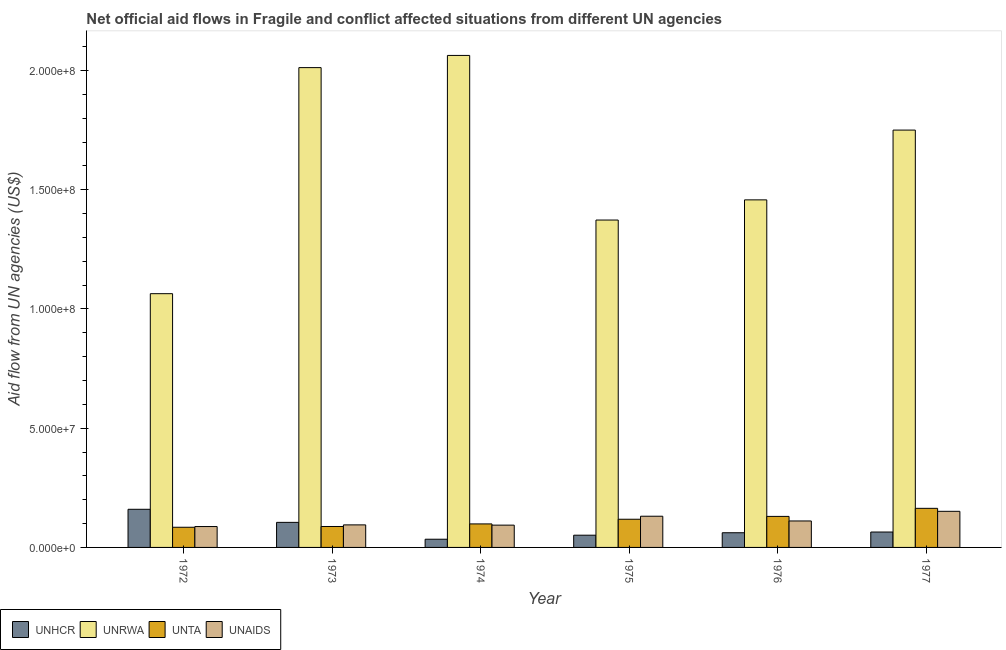How many different coloured bars are there?
Provide a succinct answer. 4. How many groups of bars are there?
Ensure brevity in your answer.  6. Are the number of bars per tick equal to the number of legend labels?
Offer a terse response. Yes. Are the number of bars on each tick of the X-axis equal?
Make the answer very short. Yes. What is the label of the 6th group of bars from the left?
Offer a very short reply. 1977. What is the amount of aid given by unta in 1975?
Offer a very short reply. 1.18e+07. Across all years, what is the maximum amount of aid given by unhcr?
Provide a short and direct response. 1.60e+07. Across all years, what is the minimum amount of aid given by unhcr?
Keep it short and to the point. 3.44e+06. In which year was the amount of aid given by unaids maximum?
Your answer should be very brief. 1977. What is the total amount of aid given by unhcr in the graph?
Offer a terse response. 4.77e+07. What is the difference between the amount of aid given by unta in 1972 and that in 1976?
Offer a very short reply. -4.55e+06. What is the difference between the amount of aid given by unrwa in 1976 and the amount of aid given by unhcr in 1975?
Give a very brief answer. 8.46e+06. What is the average amount of aid given by unaids per year?
Provide a short and direct response. 1.11e+07. In how many years, is the amount of aid given by unrwa greater than 150000000 US$?
Ensure brevity in your answer.  3. What is the ratio of the amount of aid given by unta in 1974 to that in 1975?
Keep it short and to the point. 0.83. Is the difference between the amount of aid given by unta in 1972 and 1973 greater than the difference between the amount of aid given by unrwa in 1972 and 1973?
Offer a very short reply. No. What is the difference between the highest and the second highest amount of aid given by unta?
Ensure brevity in your answer.  3.38e+06. What is the difference between the highest and the lowest amount of aid given by unaids?
Offer a terse response. 6.38e+06. What does the 2nd bar from the left in 1974 represents?
Provide a succinct answer. UNRWA. What does the 4th bar from the right in 1973 represents?
Your response must be concise. UNHCR. Is it the case that in every year, the sum of the amount of aid given by unhcr and amount of aid given by unrwa is greater than the amount of aid given by unta?
Keep it short and to the point. Yes. Are all the bars in the graph horizontal?
Offer a very short reply. No. Are the values on the major ticks of Y-axis written in scientific E-notation?
Your answer should be very brief. Yes. Does the graph contain grids?
Your answer should be compact. No. Where does the legend appear in the graph?
Your response must be concise. Bottom left. How many legend labels are there?
Keep it short and to the point. 4. What is the title of the graph?
Offer a terse response. Net official aid flows in Fragile and conflict affected situations from different UN agencies. Does "CO2 damage" appear as one of the legend labels in the graph?
Offer a terse response. No. What is the label or title of the X-axis?
Your answer should be compact. Year. What is the label or title of the Y-axis?
Provide a succinct answer. Aid flow from UN agencies (US$). What is the Aid flow from UN agencies (US$) of UNHCR in 1972?
Your answer should be very brief. 1.60e+07. What is the Aid flow from UN agencies (US$) in UNRWA in 1972?
Offer a terse response. 1.06e+08. What is the Aid flow from UN agencies (US$) in UNTA in 1972?
Your answer should be very brief. 8.46e+06. What is the Aid flow from UN agencies (US$) in UNAIDS in 1972?
Ensure brevity in your answer.  8.76e+06. What is the Aid flow from UN agencies (US$) of UNHCR in 1973?
Give a very brief answer. 1.05e+07. What is the Aid flow from UN agencies (US$) of UNRWA in 1973?
Your answer should be compact. 2.01e+08. What is the Aid flow from UN agencies (US$) of UNTA in 1973?
Give a very brief answer. 8.78e+06. What is the Aid flow from UN agencies (US$) of UNAIDS in 1973?
Your answer should be very brief. 9.45e+06. What is the Aid flow from UN agencies (US$) in UNHCR in 1974?
Provide a short and direct response. 3.44e+06. What is the Aid flow from UN agencies (US$) in UNRWA in 1974?
Give a very brief answer. 2.06e+08. What is the Aid flow from UN agencies (US$) in UNTA in 1974?
Your response must be concise. 9.86e+06. What is the Aid flow from UN agencies (US$) in UNAIDS in 1974?
Your answer should be very brief. 9.35e+06. What is the Aid flow from UN agencies (US$) in UNHCR in 1975?
Offer a very short reply. 5.13e+06. What is the Aid flow from UN agencies (US$) of UNRWA in 1975?
Your response must be concise. 1.37e+08. What is the Aid flow from UN agencies (US$) of UNTA in 1975?
Give a very brief answer. 1.18e+07. What is the Aid flow from UN agencies (US$) in UNAIDS in 1975?
Provide a succinct answer. 1.31e+07. What is the Aid flow from UN agencies (US$) of UNHCR in 1976?
Your response must be concise. 6.16e+06. What is the Aid flow from UN agencies (US$) in UNRWA in 1976?
Give a very brief answer. 1.46e+08. What is the Aid flow from UN agencies (US$) of UNTA in 1976?
Keep it short and to the point. 1.30e+07. What is the Aid flow from UN agencies (US$) in UNAIDS in 1976?
Provide a short and direct response. 1.11e+07. What is the Aid flow from UN agencies (US$) of UNHCR in 1977?
Your response must be concise. 6.46e+06. What is the Aid flow from UN agencies (US$) of UNRWA in 1977?
Offer a very short reply. 1.75e+08. What is the Aid flow from UN agencies (US$) of UNTA in 1977?
Your answer should be compact. 1.64e+07. What is the Aid flow from UN agencies (US$) in UNAIDS in 1977?
Your response must be concise. 1.51e+07. Across all years, what is the maximum Aid flow from UN agencies (US$) in UNHCR?
Ensure brevity in your answer.  1.60e+07. Across all years, what is the maximum Aid flow from UN agencies (US$) in UNRWA?
Ensure brevity in your answer.  2.06e+08. Across all years, what is the maximum Aid flow from UN agencies (US$) in UNTA?
Your answer should be very brief. 1.64e+07. Across all years, what is the maximum Aid flow from UN agencies (US$) in UNAIDS?
Provide a short and direct response. 1.51e+07. Across all years, what is the minimum Aid flow from UN agencies (US$) of UNHCR?
Offer a very short reply. 3.44e+06. Across all years, what is the minimum Aid flow from UN agencies (US$) of UNRWA?
Offer a very short reply. 1.06e+08. Across all years, what is the minimum Aid flow from UN agencies (US$) in UNTA?
Offer a terse response. 8.46e+06. Across all years, what is the minimum Aid flow from UN agencies (US$) in UNAIDS?
Give a very brief answer. 8.76e+06. What is the total Aid flow from UN agencies (US$) of UNHCR in the graph?
Provide a short and direct response. 4.77e+07. What is the total Aid flow from UN agencies (US$) of UNRWA in the graph?
Your response must be concise. 9.72e+08. What is the total Aid flow from UN agencies (US$) of UNTA in the graph?
Keep it short and to the point. 6.83e+07. What is the total Aid flow from UN agencies (US$) of UNAIDS in the graph?
Make the answer very short. 6.69e+07. What is the difference between the Aid flow from UN agencies (US$) in UNHCR in 1972 and that in 1973?
Offer a very short reply. 5.48e+06. What is the difference between the Aid flow from UN agencies (US$) in UNRWA in 1972 and that in 1973?
Your answer should be very brief. -9.48e+07. What is the difference between the Aid flow from UN agencies (US$) in UNTA in 1972 and that in 1973?
Offer a very short reply. -3.20e+05. What is the difference between the Aid flow from UN agencies (US$) in UNAIDS in 1972 and that in 1973?
Your answer should be very brief. -6.90e+05. What is the difference between the Aid flow from UN agencies (US$) in UNHCR in 1972 and that in 1974?
Offer a very short reply. 1.26e+07. What is the difference between the Aid flow from UN agencies (US$) in UNRWA in 1972 and that in 1974?
Your answer should be very brief. -9.99e+07. What is the difference between the Aid flow from UN agencies (US$) of UNTA in 1972 and that in 1974?
Your answer should be very brief. -1.40e+06. What is the difference between the Aid flow from UN agencies (US$) of UNAIDS in 1972 and that in 1974?
Your answer should be compact. -5.90e+05. What is the difference between the Aid flow from UN agencies (US$) of UNHCR in 1972 and that in 1975?
Ensure brevity in your answer.  1.09e+07. What is the difference between the Aid flow from UN agencies (US$) in UNRWA in 1972 and that in 1975?
Provide a succinct answer. -3.09e+07. What is the difference between the Aid flow from UN agencies (US$) of UNTA in 1972 and that in 1975?
Provide a short and direct response. -3.36e+06. What is the difference between the Aid flow from UN agencies (US$) in UNAIDS in 1972 and that in 1975?
Your answer should be compact. -4.32e+06. What is the difference between the Aid flow from UN agencies (US$) in UNHCR in 1972 and that in 1976?
Your response must be concise. 9.83e+06. What is the difference between the Aid flow from UN agencies (US$) of UNRWA in 1972 and that in 1976?
Provide a succinct answer. -3.93e+07. What is the difference between the Aid flow from UN agencies (US$) of UNTA in 1972 and that in 1976?
Your response must be concise. -4.55e+06. What is the difference between the Aid flow from UN agencies (US$) of UNAIDS in 1972 and that in 1976?
Offer a very short reply. -2.34e+06. What is the difference between the Aid flow from UN agencies (US$) in UNHCR in 1972 and that in 1977?
Provide a succinct answer. 9.53e+06. What is the difference between the Aid flow from UN agencies (US$) in UNRWA in 1972 and that in 1977?
Your response must be concise. -6.86e+07. What is the difference between the Aid flow from UN agencies (US$) of UNTA in 1972 and that in 1977?
Provide a succinct answer. -7.93e+06. What is the difference between the Aid flow from UN agencies (US$) of UNAIDS in 1972 and that in 1977?
Your answer should be very brief. -6.38e+06. What is the difference between the Aid flow from UN agencies (US$) in UNHCR in 1973 and that in 1974?
Keep it short and to the point. 7.07e+06. What is the difference between the Aid flow from UN agencies (US$) in UNRWA in 1973 and that in 1974?
Offer a terse response. -5.11e+06. What is the difference between the Aid flow from UN agencies (US$) in UNTA in 1973 and that in 1974?
Your answer should be compact. -1.08e+06. What is the difference between the Aid flow from UN agencies (US$) of UNHCR in 1973 and that in 1975?
Give a very brief answer. 5.38e+06. What is the difference between the Aid flow from UN agencies (US$) in UNRWA in 1973 and that in 1975?
Offer a terse response. 6.39e+07. What is the difference between the Aid flow from UN agencies (US$) in UNTA in 1973 and that in 1975?
Provide a succinct answer. -3.04e+06. What is the difference between the Aid flow from UN agencies (US$) in UNAIDS in 1973 and that in 1975?
Give a very brief answer. -3.63e+06. What is the difference between the Aid flow from UN agencies (US$) in UNHCR in 1973 and that in 1976?
Your response must be concise. 4.35e+06. What is the difference between the Aid flow from UN agencies (US$) of UNRWA in 1973 and that in 1976?
Offer a terse response. 5.55e+07. What is the difference between the Aid flow from UN agencies (US$) of UNTA in 1973 and that in 1976?
Your response must be concise. -4.23e+06. What is the difference between the Aid flow from UN agencies (US$) in UNAIDS in 1973 and that in 1976?
Ensure brevity in your answer.  -1.65e+06. What is the difference between the Aid flow from UN agencies (US$) of UNHCR in 1973 and that in 1977?
Provide a short and direct response. 4.05e+06. What is the difference between the Aid flow from UN agencies (US$) in UNRWA in 1973 and that in 1977?
Provide a succinct answer. 2.62e+07. What is the difference between the Aid flow from UN agencies (US$) in UNTA in 1973 and that in 1977?
Provide a short and direct response. -7.61e+06. What is the difference between the Aid flow from UN agencies (US$) of UNAIDS in 1973 and that in 1977?
Your answer should be compact. -5.69e+06. What is the difference between the Aid flow from UN agencies (US$) in UNHCR in 1974 and that in 1975?
Give a very brief answer. -1.69e+06. What is the difference between the Aid flow from UN agencies (US$) in UNRWA in 1974 and that in 1975?
Offer a very short reply. 6.90e+07. What is the difference between the Aid flow from UN agencies (US$) of UNTA in 1974 and that in 1975?
Make the answer very short. -1.96e+06. What is the difference between the Aid flow from UN agencies (US$) in UNAIDS in 1974 and that in 1975?
Ensure brevity in your answer.  -3.73e+06. What is the difference between the Aid flow from UN agencies (US$) in UNHCR in 1974 and that in 1976?
Offer a terse response. -2.72e+06. What is the difference between the Aid flow from UN agencies (US$) in UNRWA in 1974 and that in 1976?
Make the answer very short. 6.06e+07. What is the difference between the Aid flow from UN agencies (US$) of UNTA in 1974 and that in 1976?
Keep it short and to the point. -3.15e+06. What is the difference between the Aid flow from UN agencies (US$) of UNAIDS in 1974 and that in 1976?
Your answer should be very brief. -1.75e+06. What is the difference between the Aid flow from UN agencies (US$) in UNHCR in 1974 and that in 1977?
Offer a very short reply. -3.02e+06. What is the difference between the Aid flow from UN agencies (US$) of UNRWA in 1974 and that in 1977?
Offer a terse response. 3.13e+07. What is the difference between the Aid flow from UN agencies (US$) of UNTA in 1974 and that in 1977?
Ensure brevity in your answer.  -6.53e+06. What is the difference between the Aid flow from UN agencies (US$) of UNAIDS in 1974 and that in 1977?
Your answer should be very brief. -5.79e+06. What is the difference between the Aid flow from UN agencies (US$) in UNHCR in 1975 and that in 1976?
Provide a short and direct response. -1.03e+06. What is the difference between the Aid flow from UN agencies (US$) of UNRWA in 1975 and that in 1976?
Your answer should be compact. -8.46e+06. What is the difference between the Aid flow from UN agencies (US$) of UNTA in 1975 and that in 1976?
Make the answer very short. -1.19e+06. What is the difference between the Aid flow from UN agencies (US$) in UNAIDS in 1975 and that in 1976?
Offer a very short reply. 1.98e+06. What is the difference between the Aid flow from UN agencies (US$) of UNHCR in 1975 and that in 1977?
Your response must be concise. -1.33e+06. What is the difference between the Aid flow from UN agencies (US$) in UNRWA in 1975 and that in 1977?
Keep it short and to the point. -3.77e+07. What is the difference between the Aid flow from UN agencies (US$) in UNTA in 1975 and that in 1977?
Offer a terse response. -4.57e+06. What is the difference between the Aid flow from UN agencies (US$) of UNAIDS in 1975 and that in 1977?
Keep it short and to the point. -2.06e+06. What is the difference between the Aid flow from UN agencies (US$) in UNHCR in 1976 and that in 1977?
Ensure brevity in your answer.  -3.00e+05. What is the difference between the Aid flow from UN agencies (US$) of UNRWA in 1976 and that in 1977?
Provide a succinct answer. -2.93e+07. What is the difference between the Aid flow from UN agencies (US$) in UNTA in 1976 and that in 1977?
Ensure brevity in your answer.  -3.38e+06. What is the difference between the Aid flow from UN agencies (US$) of UNAIDS in 1976 and that in 1977?
Your answer should be very brief. -4.04e+06. What is the difference between the Aid flow from UN agencies (US$) of UNHCR in 1972 and the Aid flow from UN agencies (US$) of UNRWA in 1973?
Provide a short and direct response. -1.85e+08. What is the difference between the Aid flow from UN agencies (US$) in UNHCR in 1972 and the Aid flow from UN agencies (US$) in UNTA in 1973?
Make the answer very short. 7.21e+06. What is the difference between the Aid flow from UN agencies (US$) in UNHCR in 1972 and the Aid flow from UN agencies (US$) in UNAIDS in 1973?
Your response must be concise. 6.54e+06. What is the difference between the Aid flow from UN agencies (US$) of UNRWA in 1972 and the Aid flow from UN agencies (US$) of UNTA in 1973?
Ensure brevity in your answer.  9.76e+07. What is the difference between the Aid flow from UN agencies (US$) of UNRWA in 1972 and the Aid flow from UN agencies (US$) of UNAIDS in 1973?
Keep it short and to the point. 9.70e+07. What is the difference between the Aid flow from UN agencies (US$) of UNTA in 1972 and the Aid flow from UN agencies (US$) of UNAIDS in 1973?
Provide a short and direct response. -9.90e+05. What is the difference between the Aid flow from UN agencies (US$) of UNHCR in 1972 and the Aid flow from UN agencies (US$) of UNRWA in 1974?
Your response must be concise. -1.90e+08. What is the difference between the Aid flow from UN agencies (US$) in UNHCR in 1972 and the Aid flow from UN agencies (US$) in UNTA in 1974?
Your response must be concise. 6.13e+06. What is the difference between the Aid flow from UN agencies (US$) of UNHCR in 1972 and the Aid flow from UN agencies (US$) of UNAIDS in 1974?
Provide a succinct answer. 6.64e+06. What is the difference between the Aid flow from UN agencies (US$) of UNRWA in 1972 and the Aid flow from UN agencies (US$) of UNTA in 1974?
Offer a terse response. 9.65e+07. What is the difference between the Aid flow from UN agencies (US$) of UNRWA in 1972 and the Aid flow from UN agencies (US$) of UNAIDS in 1974?
Give a very brief answer. 9.70e+07. What is the difference between the Aid flow from UN agencies (US$) in UNTA in 1972 and the Aid flow from UN agencies (US$) in UNAIDS in 1974?
Ensure brevity in your answer.  -8.90e+05. What is the difference between the Aid flow from UN agencies (US$) in UNHCR in 1972 and the Aid flow from UN agencies (US$) in UNRWA in 1975?
Offer a terse response. -1.21e+08. What is the difference between the Aid flow from UN agencies (US$) in UNHCR in 1972 and the Aid flow from UN agencies (US$) in UNTA in 1975?
Your answer should be compact. 4.17e+06. What is the difference between the Aid flow from UN agencies (US$) in UNHCR in 1972 and the Aid flow from UN agencies (US$) in UNAIDS in 1975?
Provide a short and direct response. 2.91e+06. What is the difference between the Aid flow from UN agencies (US$) in UNRWA in 1972 and the Aid flow from UN agencies (US$) in UNTA in 1975?
Make the answer very short. 9.46e+07. What is the difference between the Aid flow from UN agencies (US$) of UNRWA in 1972 and the Aid flow from UN agencies (US$) of UNAIDS in 1975?
Your answer should be compact. 9.33e+07. What is the difference between the Aid flow from UN agencies (US$) in UNTA in 1972 and the Aid flow from UN agencies (US$) in UNAIDS in 1975?
Your answer should be compact. -4.62e+06. What is the difference between the Aid flow from UN agencies (US$) in UNHCR in 1972 and the Aid flow from UN agencies (US$) in UNRWA in 1976?
Keep it short and to the point. -1.30e+08. What is the difference between the Aid flow from UN agencies (US$) of UNHCR in 1972 and the Aid flow from UN agencies (US$) of UNTA in 1976?
Offer a terse response. 2.98e+06. What is the difference between the Aid flow from UN agencies (US$) of UNHCR in 1972 and the Aid flow from UN agencies (US$) of UNAIDS in 1976?
Ensure brevity in your answer.  4.89e+06. What is the difference between the Aid flow from UN agencies (US$) in UNRWA in 1972 and the Aid flow from UN agencies (US$) in UNTA in 1976?
Keep it short and to the point. 9.34e+07. What is the difference between the Aid flow from UN agencies (US$) in UNRWA in 1972 and the Aid flow from UN agencies (US$) in UNAIDS in 1976?
Offer a very short reply. 9.53e+07. What is the difference between the Aid flow from UN agencies (US$) in UNTA in 1972 and the Aid flow from UN agencies (US$) in UNAIDS in 1976?
Offer a very short reply. -2.64e+06. What is the difference between the Aid flow from UN agencies (US$) of UNHCR in 1972 and the Aid flow from UN agencies (US$) of UNRWA in 1977?
Offer a terse response. -1.59e+08. What is the difference between the Aid flow from UN agencies (US$) of UNHCR in 1972 and the Aid flow from UN agencies (US$) of UNTA in 1977?
Your response must be concise. -4.00e+05. What is the difference between the Aid flow from UN agencies (US$) of UNHCR in 1972 and the Aid flow from UN agencies (US$) of UNAIDS in 1977?
Ensure brevity in your answer.  8.50e+05. What is the difference between the Aid flow from UN agencies (US$) of UNRWA in 1972 and the Aid flow from UN agencies (US$) of UNTA in 1977?
Offer a terse response. 9.00e+07. What is the difference between the Aid flow from UN agencies (US$) of UNRWA in 1972 and the Aid flow from UN agencies (US$) of UNAIDS in 1977?
Your answer should be compact. 9.13e+07. What is the difference between the Aid flow from UN agencies (US$) of UNTA in 1972 and the Aid flow from UN agencies (US$) of UNAIDS in 1977?
Give a very brief answer. -6.68e+06. What is the difference between the Aid flow from UN agencies (US$) in UNHCR in 1973 and the Aid flow from UN agencies (US$) in UNRWA in 1974?
Your response must be concise. -1.96e+08. What is the difference between the Aid flow from UN agencies (US$) in UNHCR in 1973 and the Aid flow from UN agencies (US$) in UNTA in 1974?
Your response must be concise. 6.50e+05. What is the difference between the Aid flow from UN agencies (US$) in UNHCR in 1973 and the Aid flow from UN agencies (US$) in UNAIDS in 1974?
Offer a terse response. 1.16e+06. What is the difference between the Aid flow from UN agencies (US$) of UNRWA in 1973 and the Aid flow from UN agencies (US$) of UNTA in 1974?
Offer a terse response. 1.91e+08. What is the difference between the Aid flow from UN agencies (US$) of UNRWA in 1973 and the Aid flow from UN agencies (US$) of UNAIDS in 1974?
Offer a terse response. 1.92e+08. What is the difference between the Aid flow from UN agencies (US$) of UNTA in 1973 and the Aid flow from UN agencies (US$) of UNAIDS in 1974?
Your answer should be very brief. -5.70e+05. What is the difference between the Aid flow from UN agencies (US$) in UNHCR in 1973 and the Aid flow from UN agencies (US$) in UNRWA in 1975?
Offer a very short reply. -1.27e+08. What is the difference between the Aid flow from UN agencies (US$) in UNHCR in 1973 and the Aid flow from UN agencies (US$) in UNTA in 1975?
Make the answer very short. -1.31e+06. What is the difference between the Aid flow from UN agencies (US$) of UNHCR in 1973 and the Aid flow from UN agencies (US$) of UNAIDS in 1975?
Keep it short and to the point. -2.57e+06. What is the difference between the Aid flow from UN agencies (US$) in UNRWA in 1973 and the Aid flow from UN agencies (US$) in UNTA in 1975?
Provide a short and direct response. 1.89e+08. What is the difference between the Aid flow from UN agencies (US$) in UNRWA in 1973 and the Aid flow from UN agencies (US$) in UNAIDS in 1975?
Your answer should be very brief. 1.88e+08. What is the difference between the Aid flow from UN agencies (US$) of UNTA in 1973 and the Aid flow from UN agencies (US$) of UNAIDS in 1975?
Keep it short and to the point. -4.30e+06. What is the difference between the Aid flow from UN agencies (US$) of UNHCR in 1973 and the Aid flow from UN agencies (US$) of UNRWA in 1976?
Provide a succinct answer. -1.35e+08. What is the difference between the Aid flow from UN agencies (US$) of UNHCR in 1973 and the Aid flow from UN agencies (US$) of UNTA in 1976?
Your answer should be compact. -2.50e+06. What is the difference between the Aid flow from UN agencies (US$) of UNHCR in 1973 and the Aid flow from UN agencies (US$) of UNAIDS in 1976?
Your answer should be very brief. -5.90e+05. What is the difference between the Aid flow from UN agencies (US$) of UNRWA in 1973 and the Aid flow from UN agencies (US$) of UNTA in 1976?
Offer a very short reply. 1.88e+08. What is the difference between the Aid flow from UN agencies (US$) in UNRWA in 1973 and the Aid flow from UN agencies (US$) in UNAIDS in 1976?
Make the answer very short. 1.90e+08. What is the difference between the Aid flow from UN agencies (US$) in UNTA in 1973 and the Aid flow from UN agencies (US$) in UNAIDS in 1976?
Your answer should be compact. -2.32e+06. What is the difference between the Aid flow from UN agencies (US$) in UNHCR in 1973 and the Aid flow from UN agencies (US$) in UNRWA in 1977?
Keep it short and to the point. -1.64e+08. What is the difference between the Aid flow from UN agencies (US$) in UNHCR in 1973 and the Aid flow from UN agencies (US$) in UNTA in 1977?
Keep it short and to the point. -5.88e+06. What is the difference between the Aid flow from UN agencies (US$) of UNHCR in 1973 and the Aid flow from UN agencies (US$) of UNAIDS in 1977?
Provide a succinct answer. -4.63e+06. What is the difference between the Aid flow from UN agencies (US$) in UNRWA in 1973 and the Aid flow from UN agencies (US$) in UNTA in 1977?
Keep it short and to the point. 1.85e+08. What is the difference between the Aid flow from UN agencies (US$) of UNRWA in 1973 and the Aid flow from UN agencies (US$) of UNAIDS in 1977?
Give a very brief answer. 1.86e+08. What is the difference between the Aid flow from UN agencies (US$) of UNTA in 1973 and the Aid flow from UN agencies (US$) of UNAIDS in 1977?
Provide a succinct answer. -6.36e+06. What is the difference between the Aid flow from UN agencies (US$) in UNHCR in 1974 and the Aid flow from UN agencies (US$) in UNRWA in 1975?
Give a very brief answer. -1.34e+08. What is the difference between the Aid flow from UN agencies (US$) in UNHCR in 1974 and the Aid flow from UN agencies (US$) in UNTA in 1975?
Keep it short and to the point. -8.38e+06. What is the difference between the Aid flow from UN agencies (US$) of UNHCR in 1974 and the Aid flow from UN agencies (US$) of UNAIDS in 1975?
Ensure brevity in your answer.  -9.64e+06. What is the difference between the Aid flow from UN agencies (US$) in UNRWA in 1974 and the Aid flow from UN agencies (US$) in UNTA in 1975?
Keep it short and to the point. 1.94e+08. What is the difference between the Aid flow from UN agencies (US$) in UNRWA in 1974 and the Aid flow from UN agencies (US$) in UNAIDS in 1975?
Provide a succinct answer. 1.93e+08. What is the difference between the Aid flow from UN agencies (US$) of UNTA in 1974 and the Aid flow from UN agencies (US$) of UNAIDS in 1975?
Your response must be concise. -3.22e+06. What is the difference between the Aid flow from UN agencies (US$) in UNHCR in 1974 and the Aid flow from UN agencies (US$) in UNRWA in 1976?
Offer a very short reply. -1.42e+08. What is the difference between the Aid flow from UN agencies (US$) in UNHCR in 1974 and the Aid flow from UN agencies (US$) in UNTA in 1976?
Make the answer very short. -9.57e+06. What is the difference between the Aid flow from UN agencies (US$) of UNHCR in 1974 and the Aid flow from UN agencies (US$) of UNAIDS in 1976?
Keep it short and to the point. -7.66e+06. What is the difference between the Aid flow from UN agencies (US$) of UNRWA in 1974 and the Aid flow from UN agencies (US$) of UNTA in 1976?
Keep it short and to the point. 1.93e+08. What is the difference between the Aid flow from UN agencies (US$) of UNRWA in 1974 and the Aid flow from UN agencies (US$) of UNAIDS in 1976?
Your answer should be very brief. 1.95e+08. What is the difference between the Aid flow from UN agencies (US$) of UNTA in 1974 and the Aid flow from UN agencies (US$) of UNAIDS in 1976?
Keep it short and to the point. -1.24e+06. What is the difference between the Aid flow from UN agencies (US$) of UNHCR in 1974 and the Aid flow from UN agencies (US$) of UNRWA in 1977?
Ensure brevity in your answer.  -1.72e+08. What is the difference between the Aid flow from UN agencies (US$) in UNHCR in 1974 and the Aid flow from UN agencies (US$) in UNTA in 1977?
Give a very brief answer. -1.30e+07. What is the difference between the Aid flow from UN agencies (US$) in UNHCR in 1974 and the Aid flow from UN agencies (US$) in UNAIDS in 1977?
Give a very brief answer. -1.17e+07. What is the difference between the Aid flow from UN agencies (US$) of UNRWA in 1974 and the Aid flow from UN agencies (US$) of UNTA in 1977?
Your answer should be very brief. 1.90e+08. What is the difference between the Aid flow from UN agencies (US$) of UNRWA in 1974 and the Aid flow from UN agencies (US$) of UNAIDS in 1977?
Your response must be concise. 1.91e+08. What is the difference between the Aid flow from UN agencies (US$) in UNTA in 1974 and the Aid flow from UN agencies (US$) in UNAIDS in 1977?
Keep it short and to the point. -5.28e+06. What is the difference between the Aid flow from UN agencies (US$) of UNHCR in 1975 and the Aid flow from UN agencies (US$) of UNRWA in 1976?
Your response must be concise. -1.41e+08. What is the difference between the Aid flow from UN agencies (US$) in UNHCR in 1975 and the Aid flow from UN agencies (US$) in UNTA in 1976?
Provide a short and direct response. -7.88e+06. What is the difference between the Aid flow from UN agencies (US$) in UNHCR in 1975 and the Aid flow from UN agencies (US$) in UNAIDS in 1976?
Make the answer very short. -5.97e+06. What is the difference between the Aid flow from UN agencies (US$) in UNRWA in 1975 and the Aid flow from UN agencies (US$) in UNTA in 1976?
Your response must be concise. 1.24e+08. What is the difference between the Aid flow from UN agencies (US$) in UNRWA in 1975 and the Aid flow from UN agencies (US$) in UNAIDS in 1976?
Your answer should be very brief. 1.26e+08. What is the difference between the Aid flow from UN agencies (US$) of UNTA in 1975 and the Aid flow from UN agencies (US$) of UNAIDS in 1976?
Give a very brief answer. 7.20e+05. What is the difference between the Aid flow from UN agencies (US$) of UNHCR in 1975 and the Aid flow from UN agencies (US$) of UNRWA in 1977?
Offer a very short reply. -1.70e+08. What is the difference between the Aid flow from UN agencies (US$) in UNHCR in 1975 and the Aid flow from UN agencies (US$) in UNTA in 1977?
Ensure brevity in your answer.  -1.13e+07. What is the difference between the Aid flow from UN agencies (US$) of UNHCR in 1975 and the Aid flow from UN agencies (US$) of UNAIDS in 1977?
Your answer should be compact. -1.00e+07. What is the difference between the Aid flow from UN agencies (US$) in UNRWA in 1975 and the Aid flow from UN agencies (US$) in UNTA in 1977?
Your answer should be very brief. 1.21e+08. What is the difference between the Aid flow from UN agencies (US$) of UNRWA in 1975 and the Aid flow from UN agencies (US$) of UNAIDS in 1977?
Provide a short and direct response. 1.22e+08. What is the difference between the Aid flow from UN agencies (US$) in UNTA in 1975 and the Aid flow from UN agencies (US$) in UNAIDS in 1977?
Keep it short and to the point. -3.32e+06. What is the difference between the Aid flow from UN agencies (US$) of UNHCR in 1976 and the Aid flow from UN agencies (US$) of UNRWA in 1977?
Your answer should be compact. -1.69e+08. What is the difference between the Aid flow from UN agencies (US$) of UNHCR in 1976 and the Aid flow from UN agencies (US$) of UNTA in 1977?
Your response must be concise. -1.02e+07. What is the difference between the Aid flow from UN agencies (US$) in UNHCR in 1976 and the Aid flow from UN agencies (US$) in UNAIDS in 1977?
Make the answer very short. -8.98e+06. What is the difference between the Aid flow from UN agencies (US$) in UNRWA in 1976 and the Aid flow from UN agencies (US$) in UNTA in 1977?
Give a very brief answer. 1.29e+08. What is the difference between the Aid flow from UN agencies (US$) of UNRWA in 1976 and the Aid flow from UN agencies (US$) of UNAIDS in 1977?
Give a very brief answer. 1.31e+08. What is the difference between the Aid flow from UN agencies (US$) in UNTA in 1976 and the Aid flow from UN agencies (US$) in UNAIDS in 1977?
Provide a succinct answer. -2.13e+06. What is the average Aid flow from UN agencies (US$) of UNHCR per year?
Keep it short and to the point. 7.95e+06. What is the average Aid flow from UN agencies (US$) in UNRWA per year?
Your answer should be very brief. 1.62e+08. What is the average Aid flow from UN agencies (US$) in UNTA per year?
Your answer should be compact. 1.14e+07. What is the average Aid flow from UN agencies (US$) in UNAIDS per year?
Provide a succinct answer. 1.11e+07. In the year 1972, what is the difference between the Aid flow from UN agencies (US$) in UNHCR and Aid flow from UN agencies (US$) in UNRWA?
Provide a succinct answer. -9.04e+07. In the year 1972, what is the difference between the Aid flow from UN agencies (US$) in UNHCR and Aid flow from UN agencies (US$) in UNTA?
Your response must be concise. 7.53e+06. In the year 1972, what is the difference between the Aid flow from UN agencies (US$) of UNHCR and Aid flow from UN agencies (US$) of UNAIDS?
Provide a short and direct response. 7.23e+06. In the year 1972, what is the difference between the Aid flow from UN agencies (US$) of UNRWA and Aid flow from UN agencies (US$) of UNTA?
Keep it short and to the point. 9.79e+07. In the year 1972, what is the difference between the Aid flow from UN agencies (US$) of UNRWA and Aid flow from UN agencies (US$) of UNAIDS?
Offer a very short reply. 9.76e+07. In the year 1972, what is the difference between the Aid flow from UN agencies (US$) in UNTA and Aid flow from UN agencies (US$) in UNAIDS?
Offer a terse response. -3.00e+05. In the year 1973, what is the difference between the Aid flow from UN agencies (US$) in UNHCR and Aid flow from UN agencies (US$) in UNRWA?
Make the answer very short. -1.91e+08. In the year 1973, what is the difference between the Aid flow from UN agencies (US$) in UNHCR and Aid flow from UN agencies (US$) in UNTA?
Provide a succinct answer. 1.73e+06. In the year 1973, what is the difference between the Aid flow from UN agencies (US$) of UNHCR and Aid flow from UN agencies (US$) of UNAIDS?
Provide a short and direct response. 1.06e+06. In the year 1973, what is the difference between the Aid flow from UN agencies (US$) in UNRWA and Aid flow from UN agencies (US$) in UNTA?
Your answer should be compact. 1.92e+08. In the year 1973, what is the difference between the Aid flow from UN agencies (US$) of UNRWA and Aid flow from UN agencies (US$) of UNAIDS?
Keep it short and to the point. 1.92e+08. In the year 1973, what is the difference between the Aid flow from UN agencies (US$) of UNTA and Aid flow from UN agencies (US$) of UNAIDS?
Offer a terse response. -6.70e+05. In the year 1974, what is the difference between the Aid flow from UN agencies (US$) in UNHCR and Aid flow from UN agencies (US$) in UNRWA?
Offer a very short reply. -2.03e+08. In the year 1974, what is the difference between the Aid flow from UN agencies (US$) in UNHCR and Aid flow from UN agencies (US$) in UNTA?
Offer a very short reply. -6.42e+06. In the year 1974, what is the difference between the Aid flow from UN agencies (US$) of UNHCR and Aid flow from UN agencies (US$) of UNAIDS?
Make the answer very short. -5.91e+06. In the year 1974, what is the difference between the Aid flow from UN agencies (US$) in UNRWA and Aid flow from UN agencies (US$) in UNTA?
Your answer should be compact. 1.96e+08. In the year 1974, what is the difference between the Aid flow from UN agencies (US$) in UNRWA and Aid flow from UN agencies (US$) in UNAIDS?
Your answer should be compact. 1.97e+08. In the year 1974, what is the difference between the Aid flow from UN agencies (US$) of UNTA and Aid flow from UN agencies (US$) of UNAIDS?
Your response must be concise. 5.10e+05. In the year 1975, what is the difference between the Aid flow from UN agencies (US$) of UNHCR and Aid flow from UN agencies (US$) of UNRWA?
Offer a very short reply. -1.32e+08. In the year 1975, what is the difference between the Aid flow from UN agencies (US$) in UNHCR and Aid flow from UN agencies (US$) in UNTA?
Give a very brief answer. -6.69e+06. In the year 1975, what is the difference between the Aid flow from UN agencies (US$) in UNHCR and Aid flow from UN agencies (US$) in UNAIDS?
Provide a succinct answer. -7.95e+06. In the year 1975, what is the difference between the Aid flow from UN agencies (US$) of UNRWA and Aid flow from UN agencies (US$) of UNTA?
Keep it short and to the point. 1.25e+08. In the year 1975, what is the difference between the Aid flow from UN agencies (US$) in UNRWA and Aid flow from UN agencies (US$) in UNAIDS?
Offer a terse response. 1.24e+08. In the year 1975, what is the difference between the Aid flow from UN agencies (US$) of UNTA and Aid flow from UN agencies (US$) of UNAIDS?
Make the answer very short. -1.26e+06. In the year 1976, what is the difference between the Aid flow from UN agencies (US$) in UNHCR and Aid flow from UN agencies (US$) in UNRWA?
Your response must be concise. -1.40e+08. In the year 1976, what is the difference between the Aid flow from UN agencies (US$) in UNHCR and Aid flow from UN agencies (US$) in UNTA?
Your answer should be compact. -6.85e+06. In the year 1976, what is the difference between the Aid flow from UN agencies (US$) of UNHCR and Aid flow from UN agencies (US$) of UNAIDS?
Ensure brevity in your answer.  -4.94e+06. In the year 1976, what is the difference between the Aid flow from UN agencies (US$) in UNRWA and Aid flow from UN agencies (US$) in UNTA?
Provide a short and direct response. 1.33e+08. In the year 1976, what is the difference between the Aid flow from UN agencies (US$) of UNRWA and Aid flow from UN agencies (US$) of UNAIDS?
Your answer should be compact. 1.35e+08. In the year 1976, what is the difference between the Aid flow from UN agencies (US$) in UNTA and Aid flow from UN agencies (US$) in UNAIDS?
Provide a succinct answer. 1.91e+06. In the year 1977, what is the difference between the Aid flow from UN agencies (US$) in UNHCR and Aid flow from UN agencies (US$) in UNRWA?
Ensure brevity in your answer.  -1.69e+08. In the year 1977, what is the difference between the Aid flow from UN agencies (US$) of UNHCR and Aid flow from UN agencies (US$) of UNTA?
Give a very brief answer. -9.93e+06. In the year 1977, what is the difference between the Aid flow from UN agencies (US$) of UNHCR and Aid flow from UN agencies (US$) of UNAIDS?
Keep it short and to the point. -8.68e+06. In the year 1977, what is the difference between the Aid flow from UN agencies (US$) of UNRWA and Aid flow from UN agencies (US$) of UNTA?
Ensure brevity in your answer.  1.59e+08. In the year 1977, what is the difference between the Aid flow from UN agencies (US$) of UNRWA and Aid flow from UN agencies (US$) of UNAIDS?
Offer a terse response. 1.60e+08. In the year 1977, what is the difference between the Aid flow from UN agencies (US$) in UNTA and Aid flow from UN agencies (US$) in UNAIDS?
Make the answer very short. 1.25e+06. What is the ratio of the Aid flow from UN agencies (US$) in UNHCR in 1972 to that in 1973?
Keep it short and to the point. 1.52. What is the ratio of the Aid flow from UN agencies (US$) in UNRWA in 1972 to that in 1973?
Offer a very short reply. 0.53. What is the ratio of the Aid flow from UN agencies (US$) of UNTA in 1972 to that in 1973?
Your response must be concise. 0.96. What is the ratio of the Aid flow from UN agencies (US$) in UNAIDS in 1972 to that in 1973?
Your answer should be compact. 0.93. What is the ratio of the Aid flow from UN agencies (US$) in UNHCR in 1972 to that in 1974?
Your answer should be very brief. 4.65. What is the ratio of the Aid flow from UN agencies (US$) of UNRWA in 1972 to that in 1974?
Your answer should be very brief. 0.52. What is the ratio of the Aid flow from UN agencies (US$) in UNTA in 1972 to that in 1974?
Your answer should be compact. 0.86. What is the ratio of the Aid flow from UN agencies (US$) in UNAIDS in 1972 to that in 1974?
Give a very brief answer. 0.94. What is the ratio of the Aid flow from UN agencies (US$) of UNHCR in 1972 to that in 1975?
Ensure brevity in your answer.  3.12. What is the ratio of the Aid flow from UN agencies (US$) of UNRWA in 1972 to that in 1975?
Keep it short and to the point. 0.78. What is the ratio of the Aid flow from UN agencies (US$) in UNTA in 1972 to that in 1975?
Keep it short and to the point. 0.72. What is the ratio of the Aid flow from UN agencies (US$) of UNAIDS in 1972 to that in 1975?
Ensure brevity in your answer.  0.67. What is the ratio of the Aid flow from UN agencies (US$) of UNHCR in 1972 to that in 1976?
Your response must be concise. 2.6. What is the ratio of the Aid flow from UN agencies (US$) of UNRWA in 1972 to that in 1976?
Provide a short and direct response. 0.73. What is the ratio of the Aid flow from UN agencies (US$) in UNTA in 1972 to that in 1976?
Ensure brevity in your answer.  0.65. What is the ratio of the Aid flow from UN agencies (US$) in UNAIDS in 1972 to that in 1976?
Ensure brevity in your answer.  0.79. What is the ratio of the Aid flow from UN agencies (US$) in UNHCR in 1972 to that in 1977?
Keep it short and to the point. 2.48. What is the ratio of the Aid flow from UN agencies (US$) in UNRWA in 1972 to that in 1977?
Make the answer very short. 0.61. What is the ratio of the Aid flow from UN agencies (US$) in UNTA in 1972 to that in 1977?
Provide a short and direct response. 0.52. What is the ratio of the Aid flow from UN agencies (US$) of UNAIDS in 1972 to that in 1977?
Give a very brief answer. 0.58. What is the ratio of the Aid flow from UN agencies (US$) of UNHCR in 1973 to that in 1974?
Offer a very short reply. 3.06. What is the ratio of the Aid flow from UN agencies (US$) in UNRWA in 1973 to that in 1974?
Keep it short and to the point. 0.98. What is the ratio of the Aid flow from UN agencies (US$) of UNTA in 1973 to that in 1974?
Ensure brevity in your answer.  0.89. What is the ratio of the Aid flow from UN agencies (US$) in UNAIDS in 1973 to that in 1974?
Offer a terse response. 1.01. What is the ratio of the Aid flow from UN agencies (US$) in UNHCR in 1973 to that in 1975?
Offer a very short reply. 2.05. What is the ratio of the Aid flow from UN agencies (US$) in UNRWA in 1973 to that in 1975?
Your answer should be compact. 1.47. What is the ratio of the Aid flow from UN agencies (US$) in UNTA in 1973 to that in 1975?
Ensure brevity in your answer.  0.74. What is the ratio of the Aid flow from UN agencies (US$) in UNAIDS in 1973 to that in 1975?
Offer a terse response. 0.72. What is the ratio of the Aid flow from UN agencies (US$) of UNHCR in 1973 to that in 1976?
Make the answer very short. 1.71. What is the ratio of the Aid flow from UN agencies (US$) of UNRWA in 1973 to that in 1976?
Keep it short and to the point. 1.38. What is the ratio of the Aid flow from UN agencies (US$) of UNTA in 1973 to that in 1976?
Make the answer very short. 0.67. What is the ratio of the Aid flow from UN agencies (US$) of UNAIDS in 1973 to that in 1976?
Keep it short and to the point. 0.85. What is the ratio of the Aid flow from UN agencies (US$) in UNHCR in 1973 to that in 1977?
Offer a terse response. 1.63. What is the ratio of the Aid flow from UN agencies (US$) of UNRWA in 1973 to that in 1977?
Ensure brevity in your answer.  1.15. What is the ratio of the Aid flow from UN agencies (US$) in UNTA in 1973 to that in 1977?
Make the answer very short. 0.54. What is the ratio of the Aid flow from UN agencies (US$) of UNAIDS in 1973 to that in 1977?
Ensure brevity in your answer.  0.62. What is the ratio of the Aid flow from UN agencies (US$) of UNHCR in 1974 to that in 1975?
Offer a terse response. 0.67. What is the ratio of the Aid flow from UN agencies (US$) of UNRWA in 1974 to that in 1975?
Offer a very short reply. 1.5. What is the ratio of the Aid flow from UN agencies (US$) in UNTA in 1974 to that in 1975?
Provide a short and direct response. 0.83. What is the ratio of the Aid flow from UN agencies (US$) of UNAIDS in 1974 to that in 1975?
Ensure brevity in your answer.  0.71. What is the ratio of the Aid flow from UN agencies (US$) of UNHCR in 1974 to that in 1976?
Provide a succinct answer. 0.56. What is the ratio of the Aid flow from UN agencies (US$) in UNRWA in 1974 to that in 1976?
Offer a very short reply. 1.42. What is the ratio of the Aid flow from UN agencies (US$) in UNTA in 1974 to that in 1976?
Keep it short and to the point. 0.76. What is the ratio of the Aid flow from UN agencies (US$) of UNAIDS in 1974 to that in 1976?
Provide a short and direct response. 0.84. What is the ratio of the Aid flow from UN agencies (US$) of UNHCR in 1974 to that in 1977?
Offer a very short reply. 0.53. What is the ratio of the Aid flow from UN agencies (US$) in UNRWA in 1974 to that in 1977?
Give a very brief answer. 1.18. What is the ratio of the Aid flow from UN agencies (US$) in UNTA in 1974 to that in 1977?
Your answer should be compact. 0.6. What is the ratio of the Aid flow from UN agencies (US$) of UNAIDS in 1974 to that in 1977?
Provide a short and direct response. 0.62. What is the ratio of the Aid flow from UN agencies (US$) in UNHCR in 1975 to that in 1976?
Your answer should be very brief. 0.83. What is the ratio of the Aid flow from UN agencies (US$) of UNRWA in 1975 to that in 1976?
Your answer should be very brief. 0.94. What is the ratio of the Aid flow from UN agencies (US$) of UNTA in 1975 to that in 1976?
Ensure brevity in your answer.  0.91. What is the ratio of the Aid flow from UN agencies (US$) in UNAIDS in 1975 to that in 1976?
Provide a short and direct response. 1.18. What is the ratio of the Aid flow from UN agencies (US$) in UNHCR in 1975 to that in 1977?
Keep it short and to the point. 0.79. What is the ratio of the Aid flow from UN agencies (US$) of UNRWA in 1975 to that in 1977?
Provide a short and direct response. 0.78. What is the ratio of the Aid flow from UN agencies (US$) in UNTA in 1975 to that in 1977?
Offer a terse response. 0.72. What is the ratio of the Aid flow from UN agencies (US$) in UNAIDS in 1975 to that in 1977?
Your response must be concise. 0.86. What is the ratio of the Aid flow from UN agencies (US$) in UNHCR in 1976 to that in 1977?
Keep it short and to the point. 0.95. What is the ratio of the Aid flow from UN agencies (US$) in UNRWA in 1976 to that in 1977?
Ensure brevity in your answer.  0.83. What is the ratio of the Aid flow from UN agencies (US$) of UNTA in 1976 to that in 1977?
Your answer should be very brief. 0.79. What is the ratio of the Aid flow from UN agencies (US$) in UNAIDS in 1976 to that in 1977?
Offer a terse response. 0.73. What is the difference between the highest and the second highest Aid flow from UN agencies (US$) in UNHCR?
Offer a terse response. 5.48e+06. What is the difference between the highest and the second highest Aid flow from UN agencies (US$) of UNRWA?
Keep it short and to the point. 5.11e+06. What is the difference between the highest and the second highest Aid flow from UN agencies (US$) of UNTA?
Provide a short and direct response. 3.38e+06. What is the difference between the highest and the second highest Aid flow from UN agencies (US$) of UNAIDS?
Provide a short and direct response. 2.06e+06. What is the difference between the highest and the lowest Aid flow from UN agencies (US$) of UNHCR?
Your answer should be very brief. 1.26e+07. What is the difference between the highest and the lowest Aid flow from UN agencies (US$) in UNRWA?
Your response must be concise. 9.99e+07. What is the difference between the highest and the lowest Aid flow from UN agencies (US$) of UNTA?
Ensure brevity in your answer.  7.93e+06. What is the difference between the highest and the lowest Aid flow from UN agencies (US$) in UNAIDS?
Ensure brevity in your answer.  6.38e+06. 